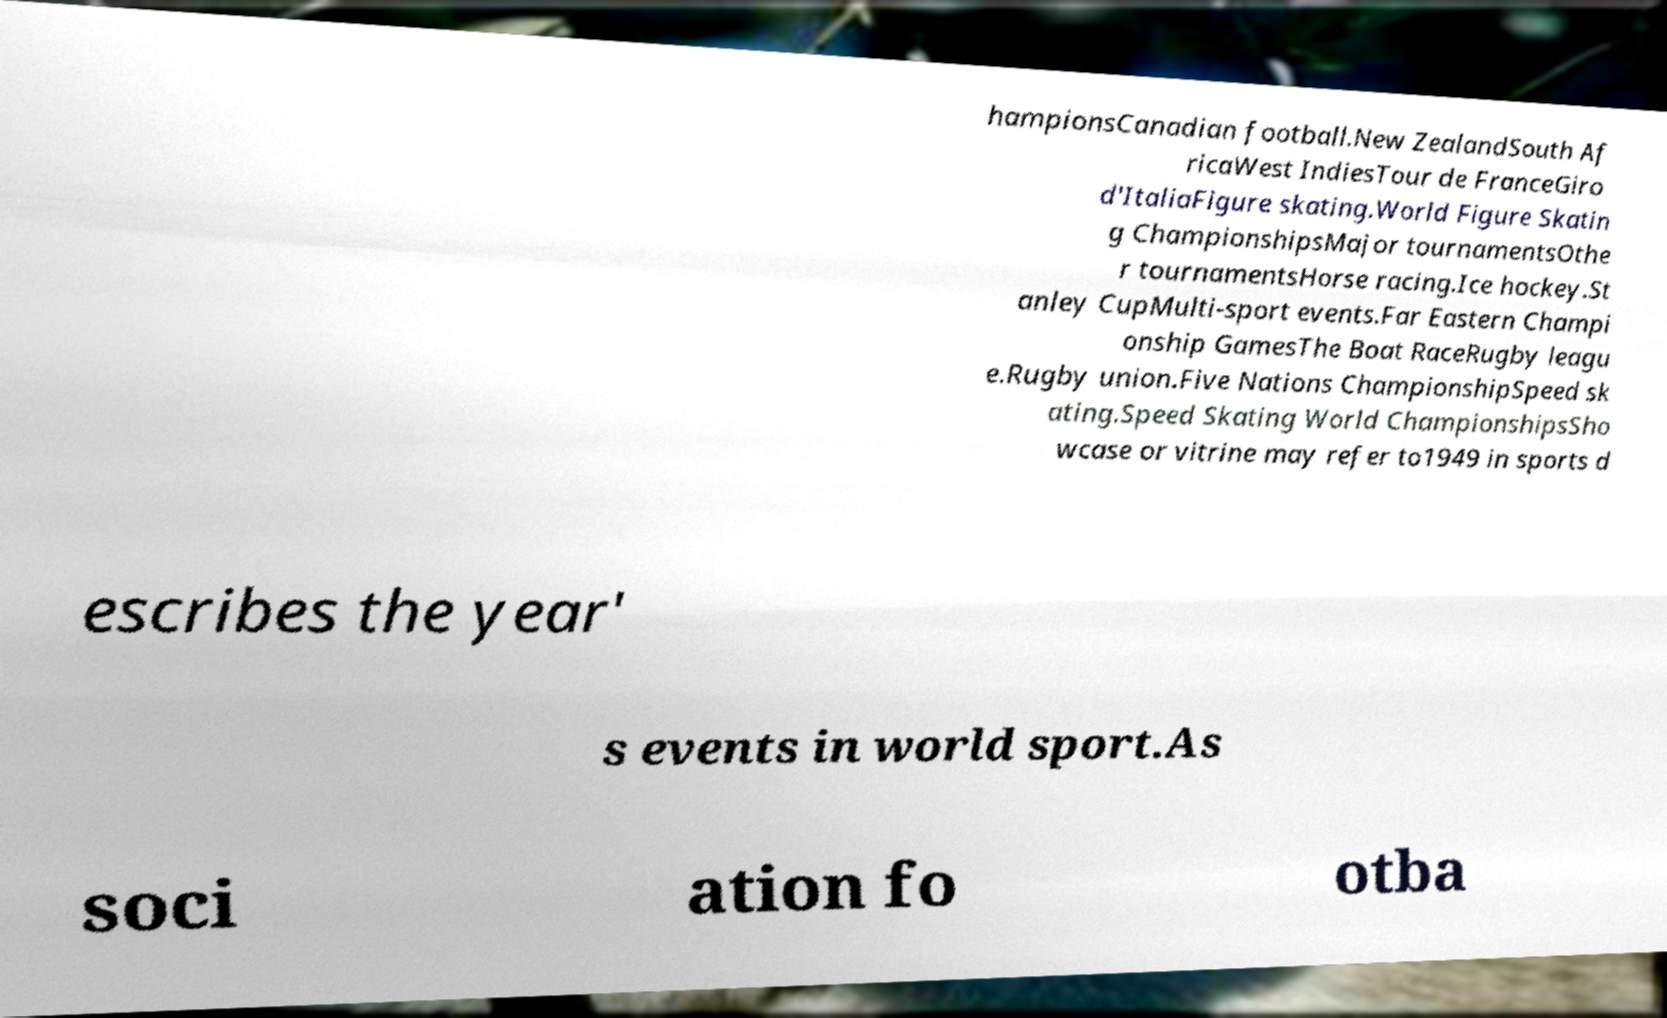Could you assist in decoding the text presented in this image and type it out clearly? hampionsCanadian football.New ZealandSouth Af ricaWest IndiesTour de FranceGiro d'ItaliaFigure skating.World Figure Skatin g ChampionshipsMajor tournamentsOthe r tournamentsHorse racing.Ice hockey.St anley CupMulti-sport events.Far Eastern Champi onship GamesThe Boat RaceRugby leagu e.Rugby union.Five Nations ChampionshipSpeed sk ating.Speed Skating World ChampionshipsSho wcase or vitrine may refer to1949 in sports d escribes the year' s events in world sport.As soci ation fo otba 